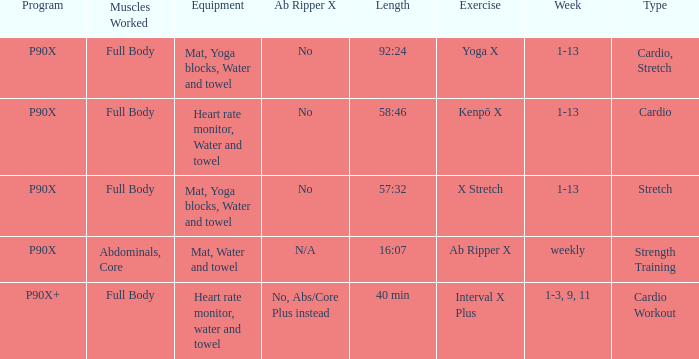Parse the full table. {'header': ['Program', 'Muscles Worked', 'Equipment', 'Ab Ripper X', 'Length', 'Exercise', 'Week', 'Type'], 'rows': [['P90X', 'Full Body', 'Mat, Yoga blocks, Water and towel', 'No', '92:24', 'Yoga X', '1-13', 'Cardio, Stretch'], ['P90X', 'Full Body', 'Heart rate monitor, Water and towel', 'No', '58:46', 'Kenpō X', '1-13', 'Cardio'], ['P90X', 'Full Body', 'Mat, Yoga blocks, Water and towel', 'No', '57:32', 'X Stretch', '1-13', 'Stretch'], ['P90X', 'Abdominals, Core', 'Mat, Water and towel', 'N/A', '16:07', 'Ab Ripper X', 'weekly', 'Strength Training'], ['P90X+', 'Full Body', 'Heart rate monitor, water and towel', 'No, Abs/Core Plus instead', '40 min', 'Interval X Plus', '1-3, 9, 11', 'Cardio Workout']]} How many types are cardio? 1.0. 